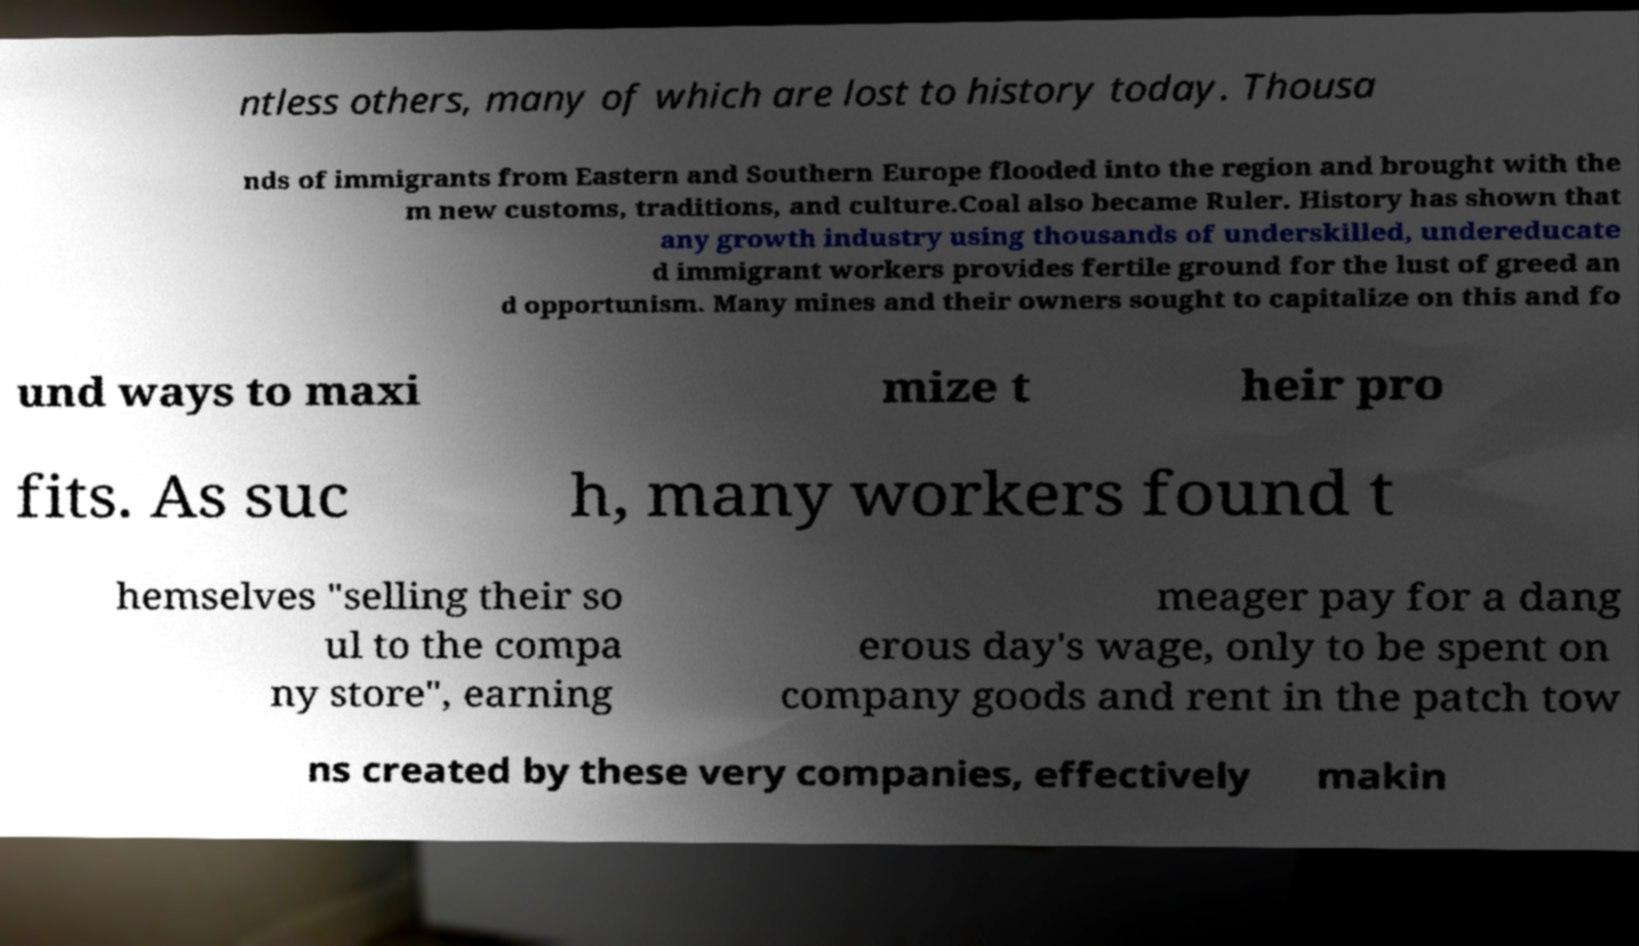Could you extract and type out the text from this image? ntless others, many of which are lost to history today. Thousa nds of immigrants from Eastern and Southern Europe flooded into the region and brought with the m new customs, traditions, and culture.Coal also became Ruler. History has shown that any growth industry using thousands of underskilled, undereducate d immigrant workers provides fertile ground for the lust of greed an d opportunism. Many mines and their owners sought to capitalize on this and fo und ways to maxi mize t heir pro fits. As suc h, many workers found t hemselves "selling their so ul to the compa ny store", earning meager pay for a dang erous day's wage, only to be spent on company goods and rent in the patch tow ns created by these very companies, effectively makin 